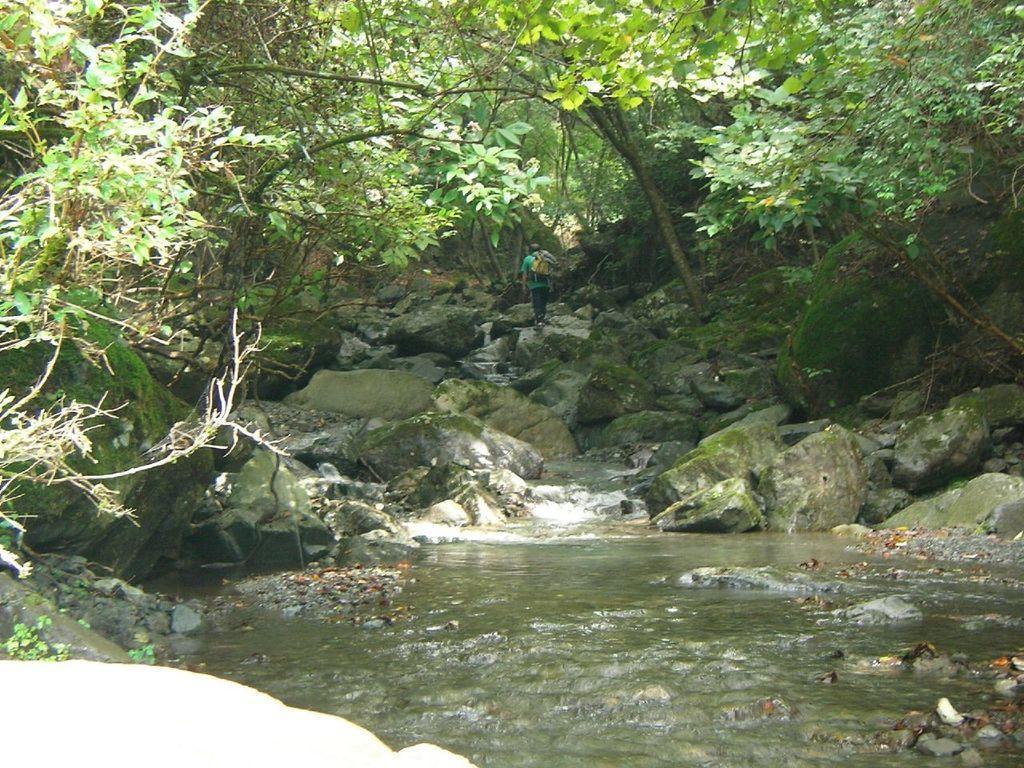Please provide a concise description of this image. In the background we can see trees, a person walking wearing a green t-shirt. We can also see rocks, water and small plants. 